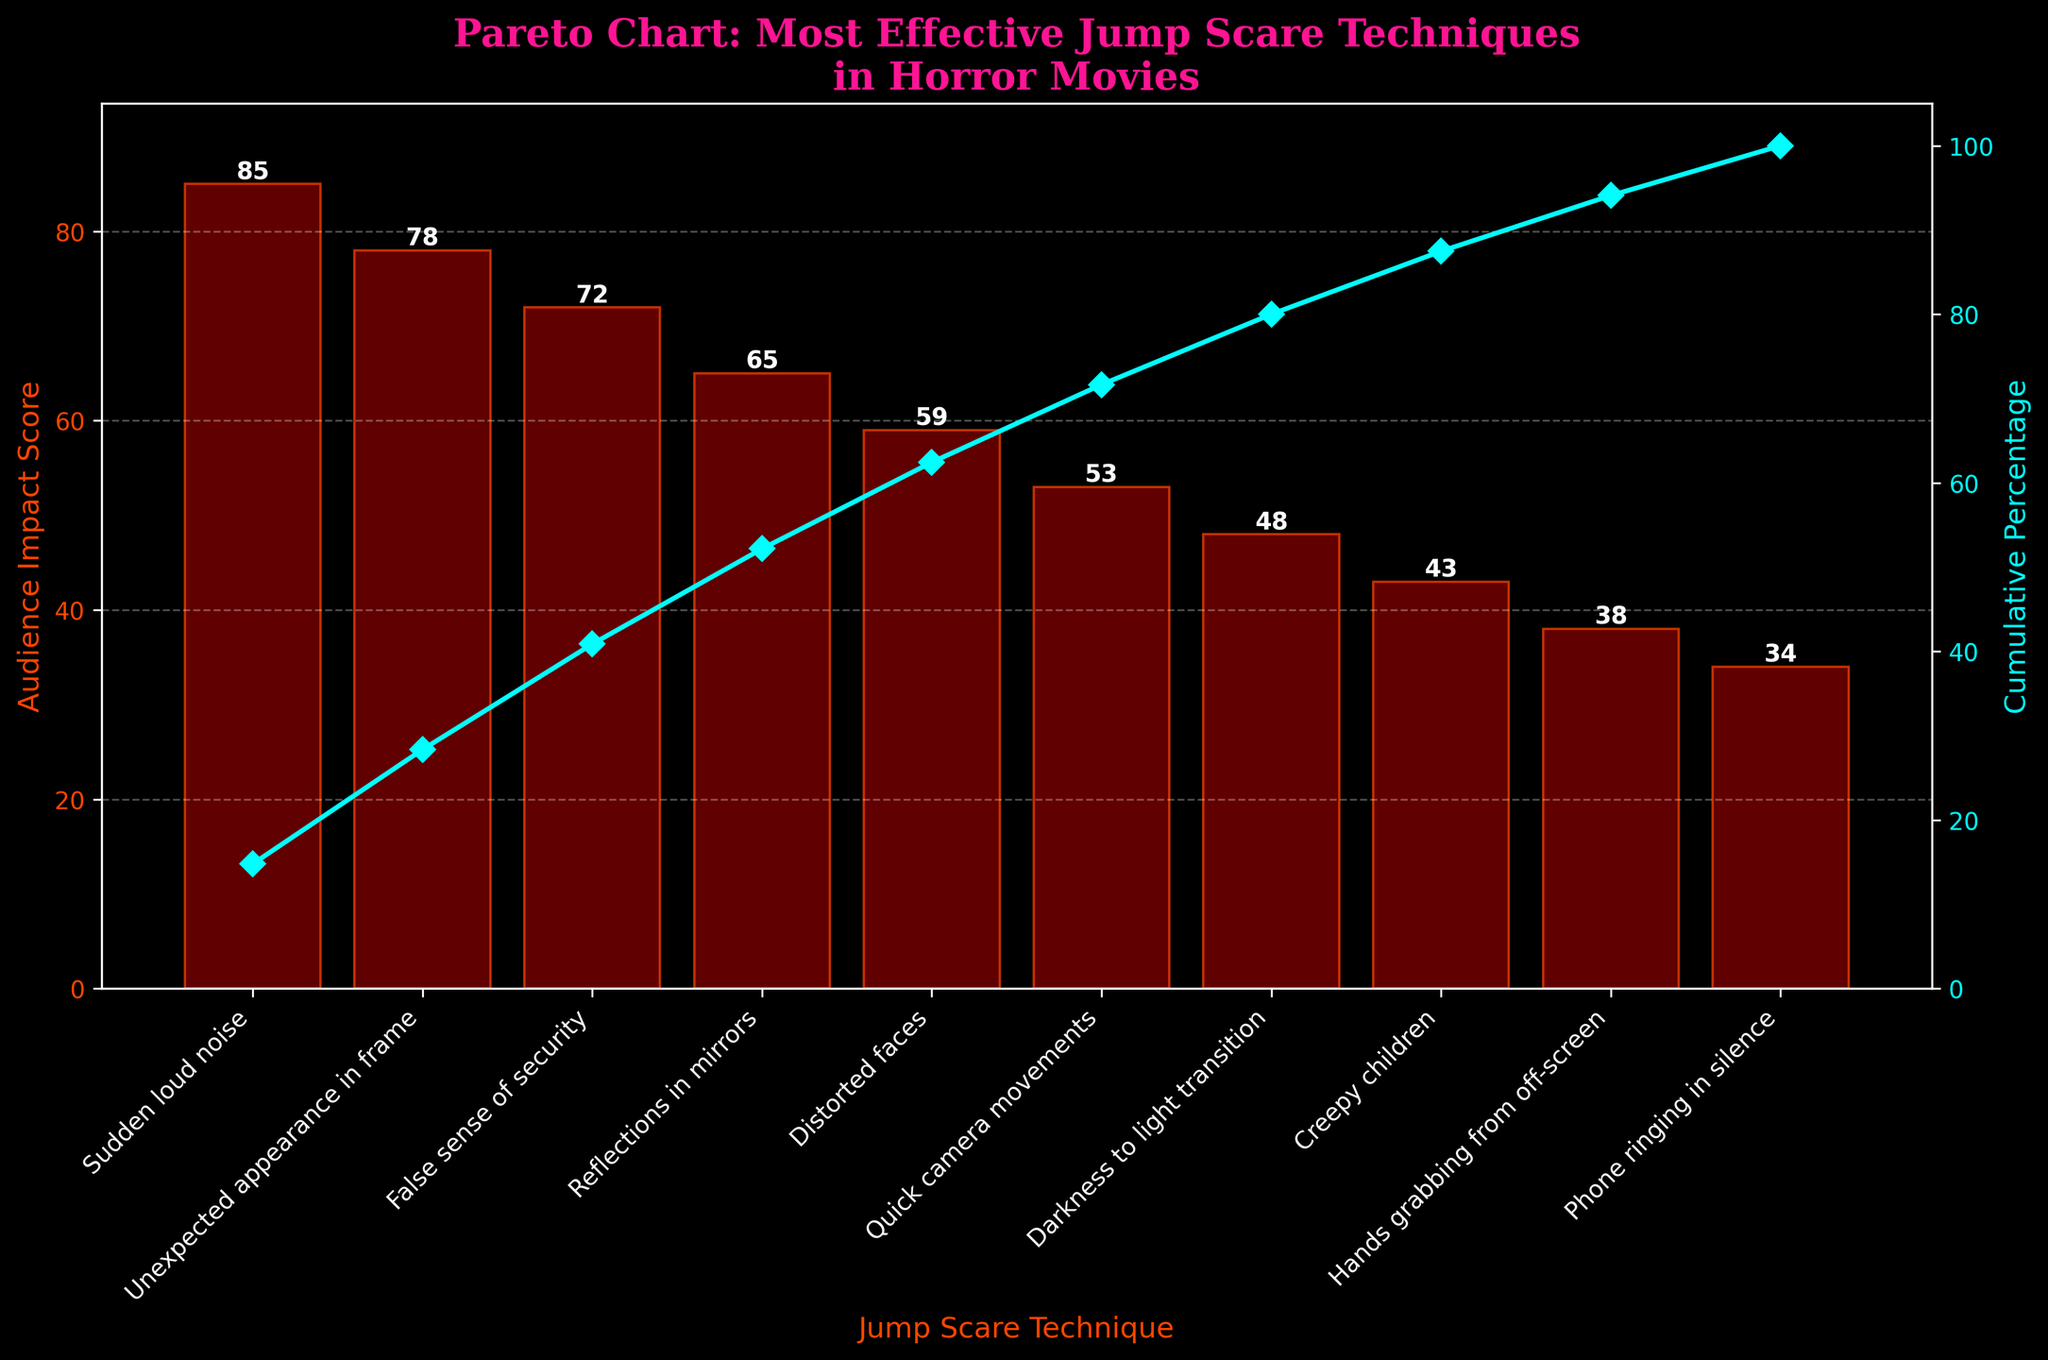What's the highest Audience Impact Score among the techniques? We look at the bar heights and identify the highest one. The one labeled "Sudden loud noise" has the highest value of 85.
Answer: 85 What technique ranks third in Audience Impact Score? By referring to the order of bars from highest to lowest, "False sense of security" is the third one with an impact score of 72.
Answer: False sense of security What's the cumulative percentage after three techniques? We sum the values of the top three techniques: 85 (Sudden loud noise) + 78 (Unexpected appearance in frame) + 72 (False sense of security) = 235. Then divide by the total score of 575 and multiply by 100 to get 40.87%.
Answer: 40.87% How many jump scare techniques have an Audience Impact Score above 50? Count the bars with heights above 50: "Sudden loud noise", "Unexpected appearance in frame", "False sense of security", "Reflections in mirrors", "Distorted faces", and "Quick camera movements". There are 6 techniques.
Answer: 6 Which technique has the least Audience Impact Score? Look for the shortest bar which represents the technique "Phone ringing in silence" with a score of 34.
Answer: Phone ringing in silence What's the difference in Audience Impact Score between "Sudden loud noise" and "Unexpected appearance in frame"? Subtract the impact score of "Unexpected appearance in frame" from that of "Sudden loud noise": 85 - 78 = 7.
Answer: 7 What is the cumulative percentage for the first six techniques? Sum the values of the top six techniques: 85 + 78 + 72 + 65 + 59 + 53 = 412. Divide by the total score of 575 and multiply by 100 to get 71.65%.
Answer: 71.65% How does the cumulative percentage change from "Reflections in mirrors" to "Quick camera movements"? The cumulative percentage after "Reflections in mirrors" is 52.52% and after "Quick camera movements" is 61.04%. Subtracting the former from the latter: 61.04% - 52.52% = 8.52%.
Answer: 8.52% Which technique contributes to reaching the 80% cumulative percentage? We look at the cumulative percentages as they increase; "Reflections in mirrors" stops at 52.52%, the addition of "Distorted faces" reaches 63.86%, "Quick camera movements" goes up to 71.65%, adding "Darkness to light transition" reaches 79.52%. However, "Creepy children" makes it exceed 80%. Thus, "Creepy children" contributes to reaching the cumulative 80% mark.
Answer: Creepy children 